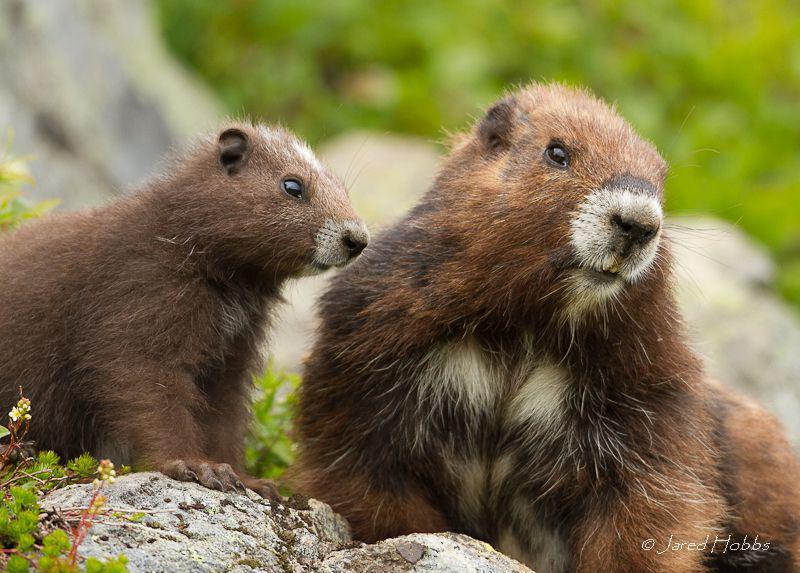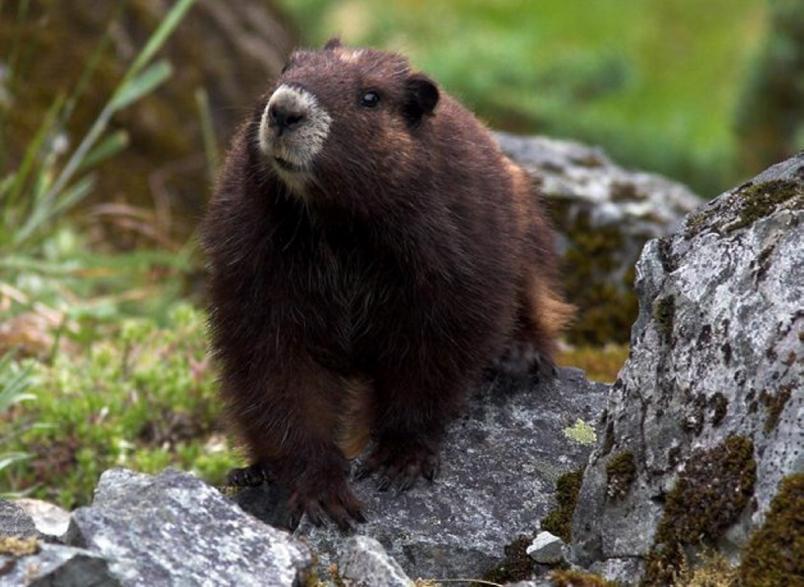The first image is the image on the left, the second image is the image on the right. For the images displayed, is the sentence "We've got three groundhogs here." factually correct? Answer yes or no. Yes. The first image is the image on the left, the second image is the image on the right. Assess this claim about the two images: "There are exactly three marmots.". Correct or not? Answer yes or no. Yes. 